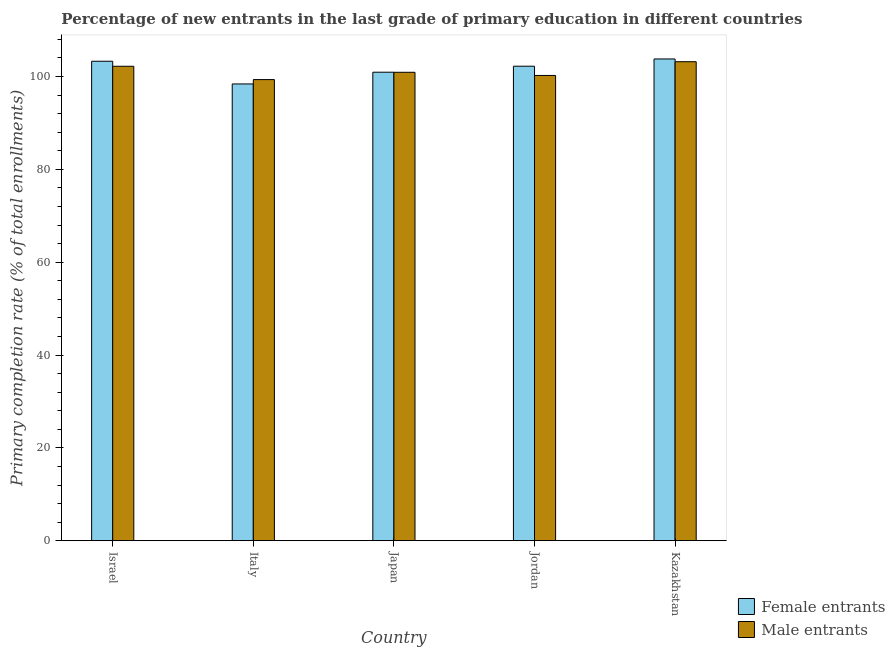How many different coloured bars are there?
Offer a very short reply. 2. How many groups of bars are there?
Your answer should be very brief. 5. How many bars are there on the 5th tick from the left?
Provide a succinct answer. 2. What is the label of the 4th group of bars from the left?
Ensure brevity in your answer.  Jordan. What is the primary completion rate of female entrants in Jordan?
Provide a succinct answer. 102.21. Across all countries, what is the maximum primary completion rate of female entrants?
Give a very brief answer. 103.77. Across all countries, what is the minimum primary completion rate of female entrants?
Provide a succinct answer. 98.39. In which country was the primary completion rate of female entrants maximum?
Provide a short and direct response. Kazakhstan. In which country was the primary completion rate of female entrants minimum?
Ensure brevity in your answer.  Italy. What is the total primary completion rate of male entrants in the graph?
Provide a succinct answer. 505.83. What is the difference between the primary completion rate of female entrants in Israel and that in Italy?
Offer a terse response. 4.89. What is the difference between the primary completion rate of male entrants in Japan and the primary completion rate of female entrants in Jordan?
Offer a very short reply. -1.31. What is the average primary completion rate of female entrants per country?
Keep it short and to the point. 101.72. What is the difference between the primary completion rate of male entrants and primary completion rate of female entrants in Israel?
Keep it short and to the point. -1.08. What is the ratio of the primary completion rate of male entrants in Italy to that in Japan?
Keep it short and to the point. 0.98. Is the primary completion rate of female entrants in Italy less than that in Jordan?
Make the answer very short. Yes. What is the difference between the highest and the second highest primary completion rate of male entrants?
Provide a short and direct response. 0.98. What is the difference between the highest and the lowest primary completion rate of male entrants?
Make the answer very short. 3.85. Is the sum of the primary completion rate of female entrants in Israel and Kazakhstan greater than the maximum primary completion rate of male entrants across all countries?
Offer a very short reply. Yes. What does the 1st bar from the left in Japan represents?
Offer a very short reply. Female entrants. What does the 1st bar from the right in Italy represents?
Provide a succinct answer. Male entrants. Are all the bars in the graph horizontal?
Ensure brevity in your answer.  No. How many countries are there in the graph?
Your response must be concise. 5. Are the values on the major ticks of Y-axis written in scientific E-notation?
Provide a short and direct response. No. How many legend labels are there?
Keep it short and to the point. 2. How are the legend labels stacked?
Your response must be concise. Vertical. What is the title of the graph?
Offer a very short reply. Percentage of new entrants in the last grade of primary education in different countries. What is the label or title of the X-axis?
Provide a succinct answer. Country. What is the label or title of the Y-axis?
Keep it short and to the point. Primary completion rate (% of total enrollments). What is the Primary completion rate (% of total enrollments) of Female entrants in Israel?
Provide a short and direct response. 103.28. What is the Primary completion rate (% of total enrollments) in Male entrants in Israel?
Ensure brevity in your answer.  102.2. What is the Primary completion rate (% of total enrollments) of Female entrants in Italy?
Your response must be concise. 98.39. What is the Primary completion rate (% of total enrollments) in Male entrants in Italy?
Keep it short and to the point. 99.33. What is the Primary completion rate (% of total enrollments) of Female entrants in Japan?
Your response must be concise. 100.92. What is the Primary completion rate (% of total enrollments) in Male entrants in Japan?
Provide a short and direct response. 100.9. What is the Primary completion rate (% of total enrollments) of Female entrants in Jordan?
Your answer should be compact. 102.21. What is the Primary completion rate (% of total enrollments) of Male entrants in Jordan?
Your answer should be very brief. 100.22. What is the Primary completion rate (% of total enrollments) of Female entrants in Kazakhstan?
Your response must be concise. 103.77. What is the Primary completion rate (% of total enrollments) of Male entrants in Kazakhstan?
Offer a terse response. 103.18. Across all countries, what is the maximum Primary completion rate (% of total enrollments) in Female entrants?
Your answer should be compact. 103.77. Across all countries, what is the maximum Primary completion rate (% of total enrollments) in Male entrants?
Ensure brevity in your answer.  103.18. Across all countries, what is the minimum Primary completion rate (% of total enrollments) in Female entrants?
Your answer should be compact. 98.39. Across all countries, what is the minimum Primary completion rate (% of total enrollments) of Male entrants?
Your answer should be very brief. 99.33. What is the total Primary completion rate (% of total enrollments) of Female entrants in the graph?
Your answer should be very brief. 508.58. What is the total Primary completion rate (% of total enrollments) in Male entrants in the graph?
Ensure brevity in your answer.  505.83. What is the difference between the Primary completion rate (% of total enrollments) of Female entrants in Israel and that in Italy?
Make the answer very short. 4.89. What is the difference between the Primary completion rate (% of total enrollments) in Male entrants in Israel and that in Italy?
Your answer should be compact. 2.87. What is the difference between the Primary completion rate (% of total enrollments) of Female entrants in Israel and that in Japan?
Provide a succinct answer. 2.36. What is the difference between the Primary completion rate (% of total enrollments) in Male entrants in Israel and that in Japan?
Ensure brevity in your answer.  1.3. What is the difference between the Primary completion rate (% of total enrollments) of Female entrants in Israel and that in Jordan?
Offer a very short reply. 1.07. What is the difference between the Primary completion rate (% of total enrollments) of Male entrants in Israel and that in Jordan?
Keep it short and to the point. 1.98. What is the difference between the Primary completion rate (% of total enrollments) in Female entrants in Israel and that in Kazakhstan?
Provide a succinct answer. -0.49. What is the difference between the Primary completion rate (% of total enrollments) in Male entrants in Israel and that in Kazakhstan?
Offer a terse response. -0.98. What is the difference between the Primary completion rate (% of total enrollments) of Female entrants in Italy and that in Japan?
Offer a very short reply. -2.53. What is the difference between the Primary completion rate (% of total enrollments) in Male entrants in Italy and that in Japan?
Provide a succinct answer. -1.57. What is the difference between the Primary completion rate (% of total enrollments) of Female entrants in Italy and that in Jordan?
Ensure brevity in your answer.  -3.82. What is the difference between the Primary completion rate (% of total enrollments) of Male entrants in Italy and that in Jordan?
Offer a terse response. -0.89. What is the difference between the Primary completion rate (% of total enrollments) of Female entrants in Italy and that in Kazakhstan?
Your answer should be very brief. -5.38. What is the difference between the Primary completion rate (% of total enrollments) in Male entrants in Italy and that in Kazakhstan?
Your response must be concise. -3.85. What is the difference between the Primary completion rate (% of total enrollments) of Female entrants in Japan and that in Jordan?
Your response must be concise. -1.29. What is the difference between the Primary completion rate (% of total enrollments) of Male entrants in Japan and that in Jordan?
Your response must be concise. 0.68. What is the difference between the Primary completion rate (% of total enrollments) of Female entrants in Japan and that in Kazakhstan?
Make the answer very short. -2.85. What is the difference between the Primary completion rate (% of total enrollments) in Male entrants in Japan and that in Kazakhstan?
Make the answer very short. -2.28. What is the difference between the Primary completion rate (% of total enrollments) in Female entrants in Jordan and that in Kazakhstan?
Give a very brief answer. -1.56. What is the difference between the Primary completion rate (% of total enrollments) of Male entrants in Jordan and that in Kazakhstan?
Provide a succinct answer. -2.96. What is the difference between the Primary completion rate (% of total enrollments) of Female entrants in Israel and the Primary completion rate (% of total enrollments) of Male entrants in Italy?
Give a very brief answer. 3.95. What is the difference between the Primary completion rate (% of total enrollments) of Female entrants in Israel and the Primary completion rate (% of total enrollments) of Male entrants in Japan?
Ensure brevity in your answer.  2.38. What is the difference between the Primary completion rate (% of total enrollments) in Female entrants in Israel and the Primary completion rate (% of total enrollments) in Male entrants in Jordan?
Your response must be concise. 3.06. What is the difference between the Primary completion rate (% of total enrollments) in Female entrants in Israel and the Primary completion rate (% of total enrollments) in Male entrants in Kazakhstan?
Give a very brief answer. 0.1. What is the difference between the Primary completion rate (% of total enrollments) in Female entrants in Italy and the Primary completion rate (% of total enrollments) in Male entrants in Japan?
Make the answer very short. -2.51. What is the difference between the Primary completion rate (% of total enrollments) of Female entrants in Italy and the Primary completion rate (% of total enrollments) of Male entrants in Jordan?
Give a very brief answer. -1.83. What is the difference between the Primary completion rate (% of total enrollments) of Female entrants in Italy and the Primary completion rate (% of total enrollments) of Male entrants in Kazakhstan?
Offer a very short reply. -4.79. What is the difference between the Primary completion rate (% of total enrollments) in Female entrants in Japan and the Primary completion rate (% of total enrollments) in Male entrants in Jordan?
Offer a very short reply. 0.7. What is the difference between the Primary completion rate (% of total enrollments) of Female entrants in Japan and the Primary completion rate (% of total enrollments) of Male entrants in Kazakhstan?
Offer a terse response. -2.26. What is the difference between the Primary completion rate (% of total enrollments) of Female entrants in Jordan and the Primary completion rate (% of total enrollments) of Male entrants in Kazakhstan?
Offer a very short reply. -0.97. What is the average Primary completion rate (% of total enrollments) of Female entrants per country?
Make the answer very short. 101.72. What is the average Primary completion rate (% of total enrollments) of Male entrants per country?
Keep it short and to the point. 101.17. What is the difference between the Primary completion rate (% of total enrollments) in Female entrants and Primary completion rate (% of total enrollments) in Male entrants in Israel?
Keep it short and to the point. 1.08. What is the difference between the Primary completion rate (% of total enrollments) in Female entrants and Primary completion rate (% of total enrollments) in Male entrants in Italy?
Offer a terse response. -0.94. What is the difference between the Primary completion rate (% of total enrollments) of Female entrants and Primary completion rate (% of total enrollments) of Male entrants in Japan?
Your response must be concise. 0.02. What is the difference between the Primary completion rate (% of total enrollments) of Female entrants and Primary completion rate (% of total enrollments) of Male entrants in Jordan?
Provide a short and direct response. 2. What is the difference between the Primary completion rate (% of total enrollments) in Female entrants and Primary completion rate (% of total enrollments) in Male entrants in Kazakhstan?
Give a very brief answer. 0.59. What is the ratio of the Primary completion rate (% of total enrollments) in Female entrants in Israel to that in Italy?
Provide a short and direct response. 1.05. What is the ratio of the Primary completion rate (% of total enrollments) of Male entrants in Israel to that in Italy?
Your response must be concise. 1.03. What is the ratio of the Primary completion rate (% of total enrollments) in Female entrants in Israel to that in Japan?
Give a very brief answer. 1.02. What is the ratio of the Primary completion rate (% of total enrollments) in Male entrants in Israel to that in Japan?
Your response must be concise. 1.01. What is the ratio of the Primary completion rate (% of total enrollments) in Female entrants in Israel to that in Jordan?
Keep it short and to the point. 1.01. What is the ratio of the Primary completion rate (% of total enrollments) in Male entrants in Israel to that in Jordan?
Ensure brevity in your answer.  1.02. What is the ratio of the Primary completion rate (% of total enrollments) of Female entrants in Israel to that in Kazakhstan?
Keep it short and to the point. 1. What is the ratio of the Primary completion rate (% of total enrollments) of Male entrants in Israel to that in Kazakhstan?
Make the answer very short. 0.99. What is the ratio of the Primary completion rate (% of total enrollments) of Male entrants in Italy to that in Japan?
Your answer should be compact. 0.98. What is the ratio of the Primary completion rate (% of total enrollments) in Female entrants in Italy to that in Jordan?
Offer a very short reply. 0.96. What is the ratio of the Primary completion rate (% of total enrollments) of Female entrants in Italy to that in Kazakhstan?
Provide a short and direct response. 0.95. What is the ratio of the Primary completion rate (% of total enrollments) in Male entrants in Italy to that in Kazakhstan?
Ensure brevity in your answer.  0.96. What is the ratio of the Primary completion rate (% of total enrollments) of Female entrants in Japan to that in Jordan?
Keep it short and to the point. 0.99. What is the ratio of the Primary completion rate (% of total enrollments) of Male entrants in Japan to that in Jordan?
Make the answer very short. 1.01. What is the ratio of the Primary completion rate (% of total enrollments) of Female entrants in Japan to that in Kazakhstan?
Your response must be concise. 0.97. What is the ratio of the Primary completion rate (% of total enrollments) of Male entrants in Japan to that in Kazakhstan?
Your answer should be very brief. 0.98. What is the ratio of the Primary completion rate (% of total enrollments) in Male entrants in Jordan to that in Kazakhstan?
Provide a succinct answer. 0.97. What is the difference between the highest and the second highest Primary completion rate (% of total enrollments) of Female entrants?
Keep it short and to the point. 0.49. What is the difference between the highest and the second highest Primary completion rate (% of total enrollments) in Male entrants?
Keep it short and to the point. 0.98. What is the difference between the highest and the lowest Primary completion rate (% of total enrollments) of Female entrants?
Your answer should be compact. 5.38. What is the difference between the highest and the lowest Primary completion rate (% of total enrollments) in Male entrants?
Make the answer very short. 3.85. 